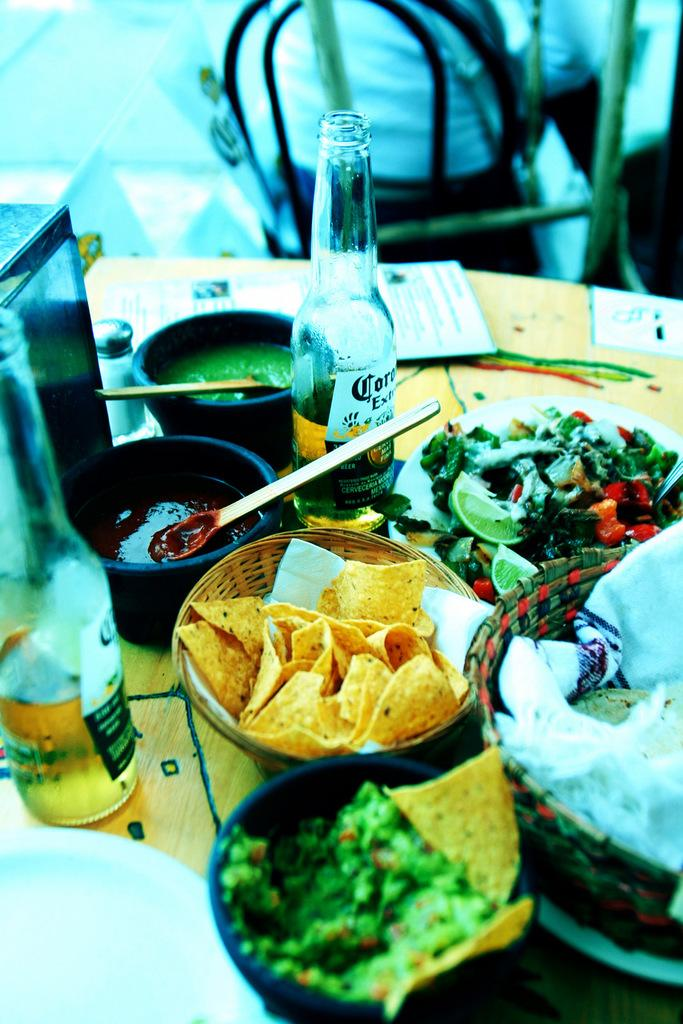Provide a one-sentence caption for the provided image. A variety of Mexican food is displayed along with two bottles of Corona. 